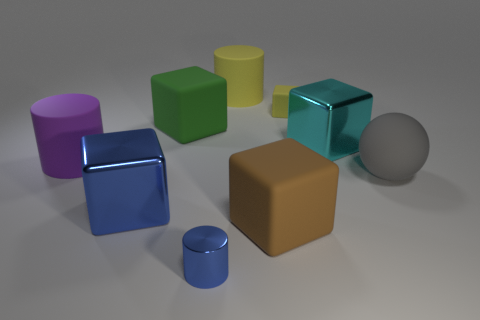Is there any other thing that has the same shape as the big gray object?
Your answer should be very brief. No. There is a purple cylinder that is the same material as the brown block; what is its size?
Provide a short and direct response. Large. Are there the same number of rubber objects that are to the left of the big blue metallic thing and big cyan shiny blocks?
Provide a succinct answer. Yes. Do the tiny thing behind the big blue shiny thing and the large shiny object that is on the left side of the yellow rubber cube have the same shape?
Provide a short and direct response. Yes. There is a yellow thing that is the same shape as the cyan metal object; what material is it?
Keep it short and to the point. Rubber. The block that is in front of the big ball and on the left side of the big brown thing is what color?
Give a very brief answer. Blue. Is there a shiny thing behind the blue metal object that is on the left side of the green matte block behind the purple matte object?
Your answer should be very brief. Yes. What number of things are cylinders or tiny red cylinders?
Your response must be concise. 3. Is the material of the big green block the same as the purple cylinder to the left of the gray matte thing?
Keep it short and to the point. Yes. Are there any other things that are the same color as the large matte sphere?
Provide a short and direct response. No. 